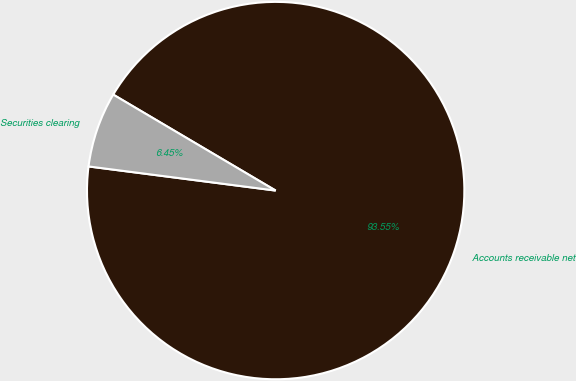Convert chart. <chart><loc_0><loc_0><loc_500><loc_500><pie_chart><fcel>Accounts receivable net<fcel>Securities clearing<nl><fcel>93.55%<fcel>6.45%<nl></chart> 